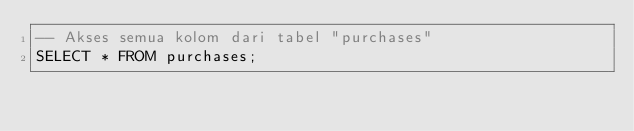<code> <loc_0><loc_0><loc_500><loc_500><_SQL_>-- Akses semua kolom dari tabel "purchases" 
SELECT * FROM purchases;
</code> 